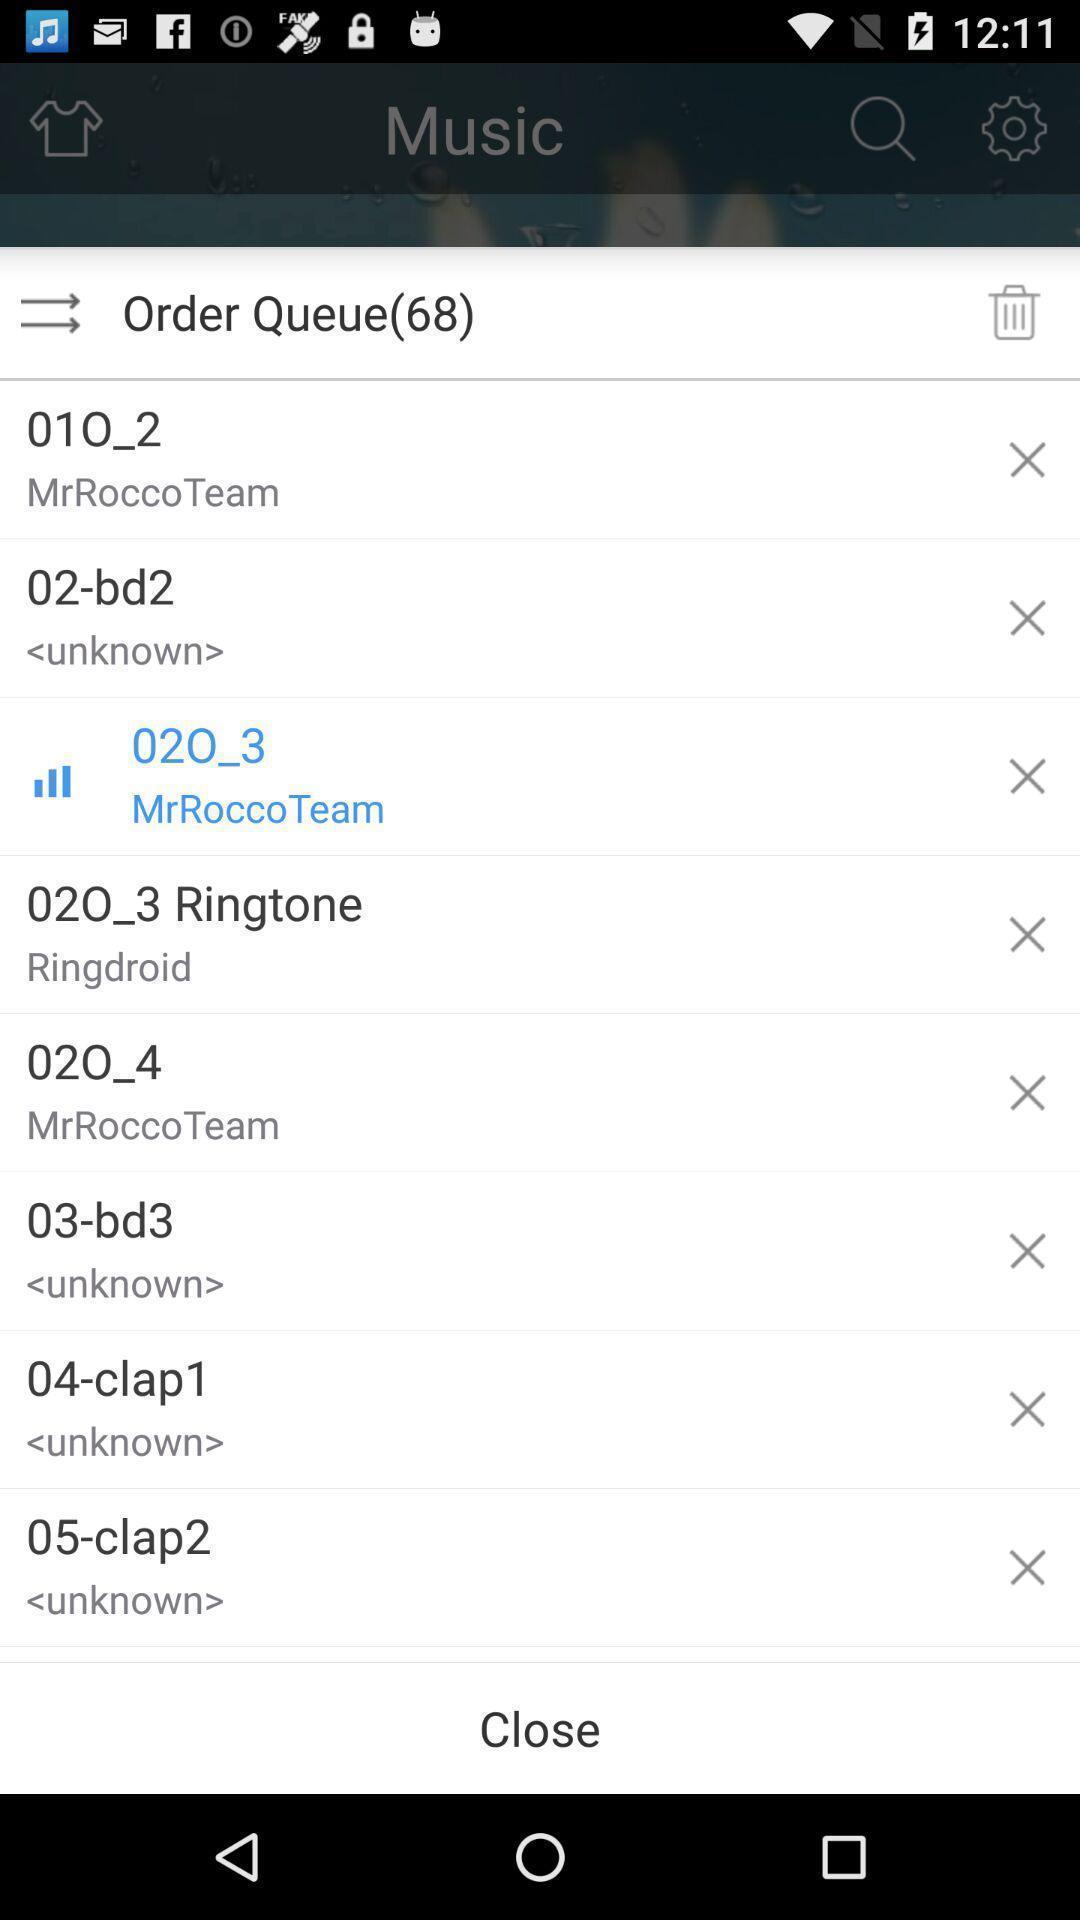Describe this image in words. Screen shows list of songs in queue in music app. 